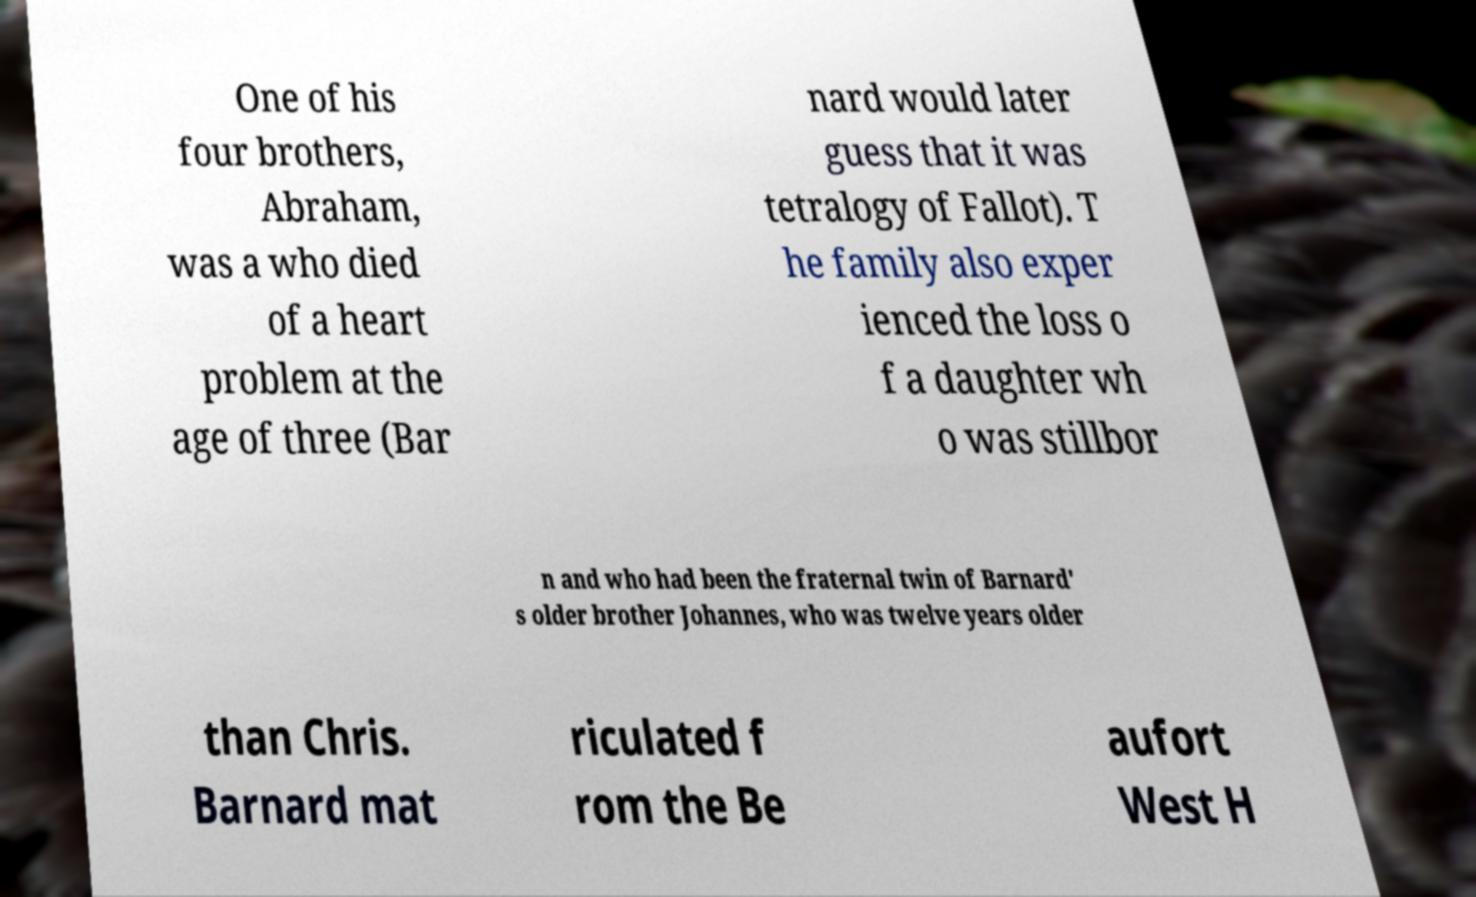There's text embedded in this image that I need extracted. Can you transcribe it verbatim? One of his four brothers, Abraham, was a who died of a heart problem at the age of three (Bar nard would later guess that it was tetralogy of Fallot). T he family also exper ienced the loss o f a daughter wh o was stillbor n and who had been the fraternal twin of Barnard' s older brother Johannes, who was twelve years older than Chris. Barnard mat riculated f rom the Be aufort West H 